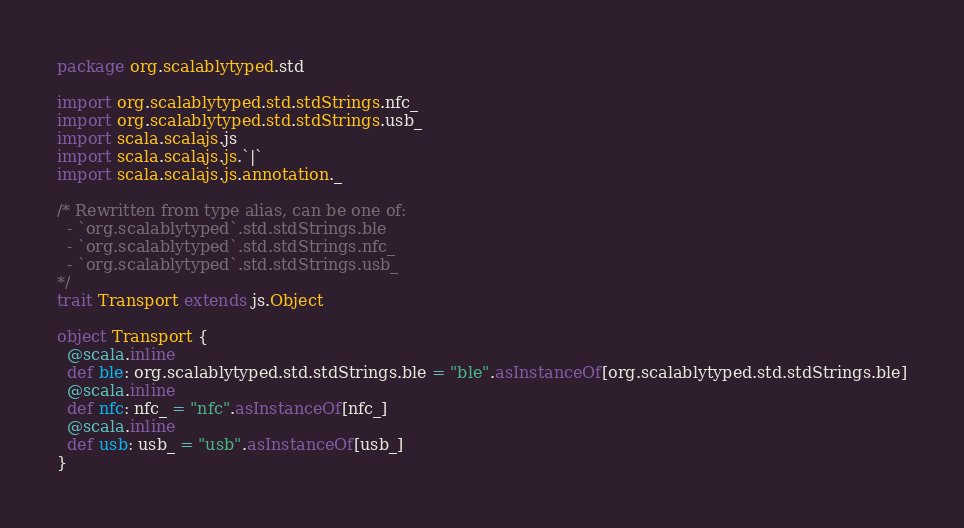<code> <loc_0><loc_0><loc_500><loc_500><_Scala_>package org.scalablytyped.std

import org.scalablytyped.std.stdStrings.nfc_
import org.scalablytyped.std.stdStrings.usb_
import scala.scalajs.js
import scala.scalajs.js.`|`
import scala.scalajs.js.annotation._

/* Rewritten from type alias, can be one of: 
  - `org.scalablytyped`.std.stdStrings.ble
  - `org.scalablytyped`.std.stdStrings.nfc_
  - `org.scalablytyped`.std.stdStrings.usb_
*/
trait Transport extends js.Object

object Transport {
  @scala.inline
  def ble: org.scalablytyped.std.stdStrings.ble = "ble".asInstanceOf[org.scalablytyped.std.stdStrings.ble]
  @scala.inline
  def nfc: nfc_ = "nfc".asInstanceOf[nfc_]
  @scala.inline
  def usb: usb_ = "usb".asInstanceOf[usb_]
}

</code> 